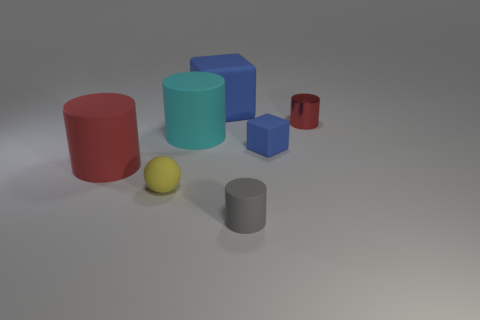Are there any other things that have the same material as the tiny red cylinder?
Your answer should be very brief. No. There is a cylinder that is in front of the red rubber cylinder; does it have the same size as the blue matte block in front of the shiny cylinder?
Give a very brief answer. Yes. How many other objects are there of the same size as the gray matte cylinder?
Make the answer very short. 3. What number of large matte cubes are in front of the rubber cube in front of the large cyan cylinder?
Provide a succinct answer. 0. Are there fewer small blue rubber blocks behind the large cyan matte thing than gray shiny blocks?
Keep it short and to the point. No. What shape is the big matte object that is on the left side of the big cylinder that is behind the big matte cylinder that is to the left of the cyan matte cylinder?
Ensure brevity in your answer.  Cylinder. Does the large cyan matte object have the same shape as the tiny red shiny thing?
Provide a short and direct response. Yes. How many other things are the same shape as the small yellow rubber object?
Ensure brevity in your answer.  0. The matte cylinder that is the same size as the cyan thing is what color?
Provide a succinct answer. Red. Are there the same number of big matte cylinders that are on the right side of the small blue rubber cube and small cyan rubber blocks?
Your answer should be compact. Yes. 